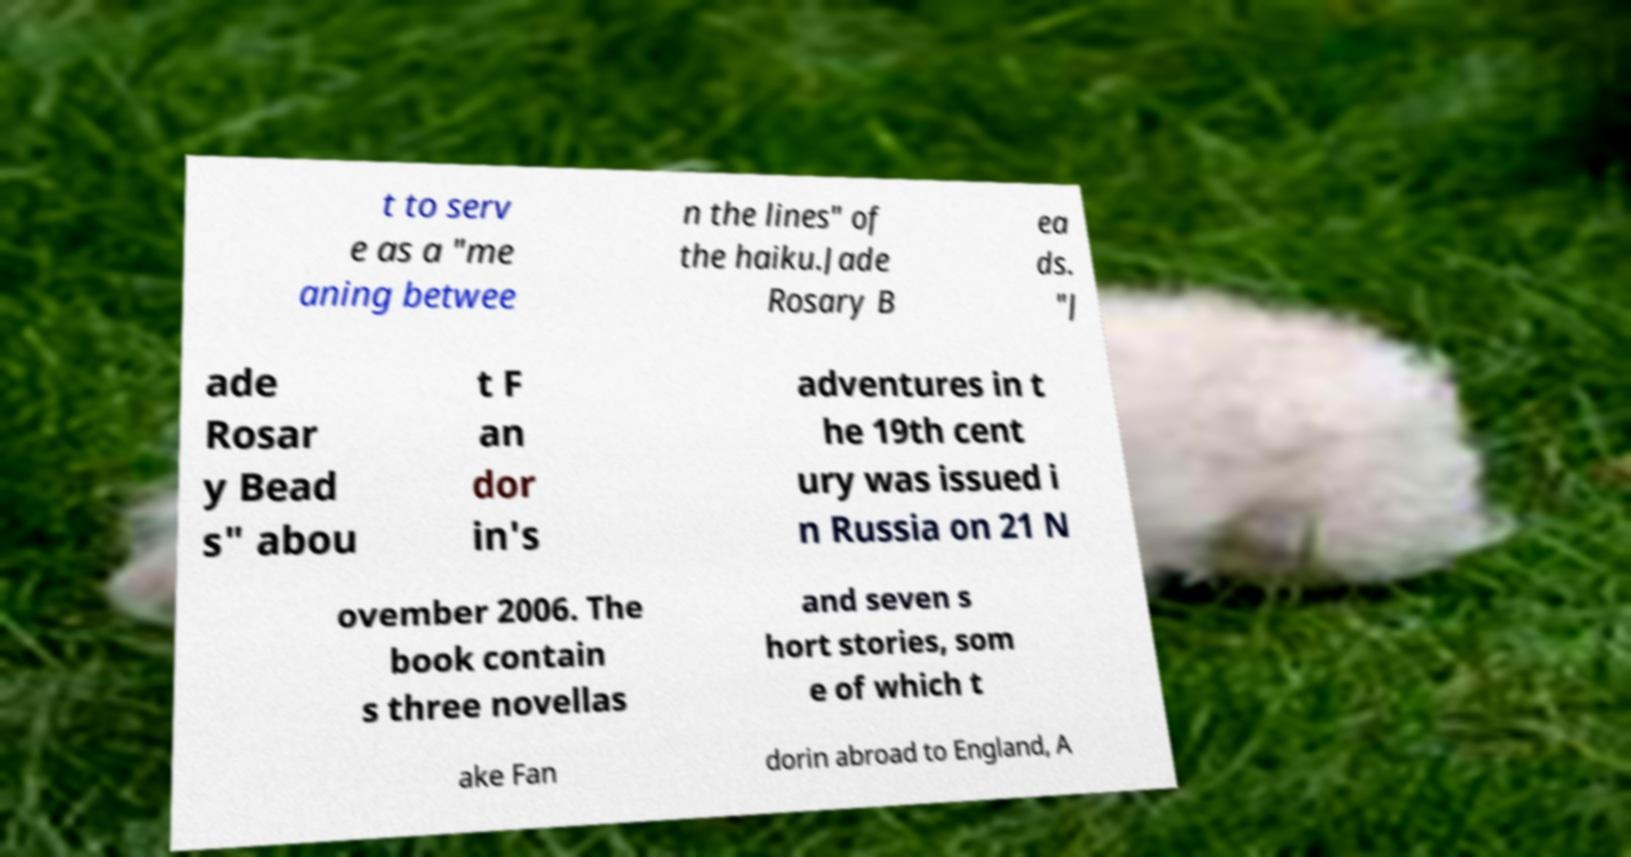Could you extract and type out the text from this image? t to serv e as a "me aning betwee n the lines" of the haiku.Jade Rosary B ea ds. "J ade Rosar y Bead s" abou t F an dor in's adventures in t he 19th cent ury was issued i n Russia on 21 N ovember 2006. The book contain s three novellas and seven s hort stories, som e of which t ake Fan dorin abroad to England, A 